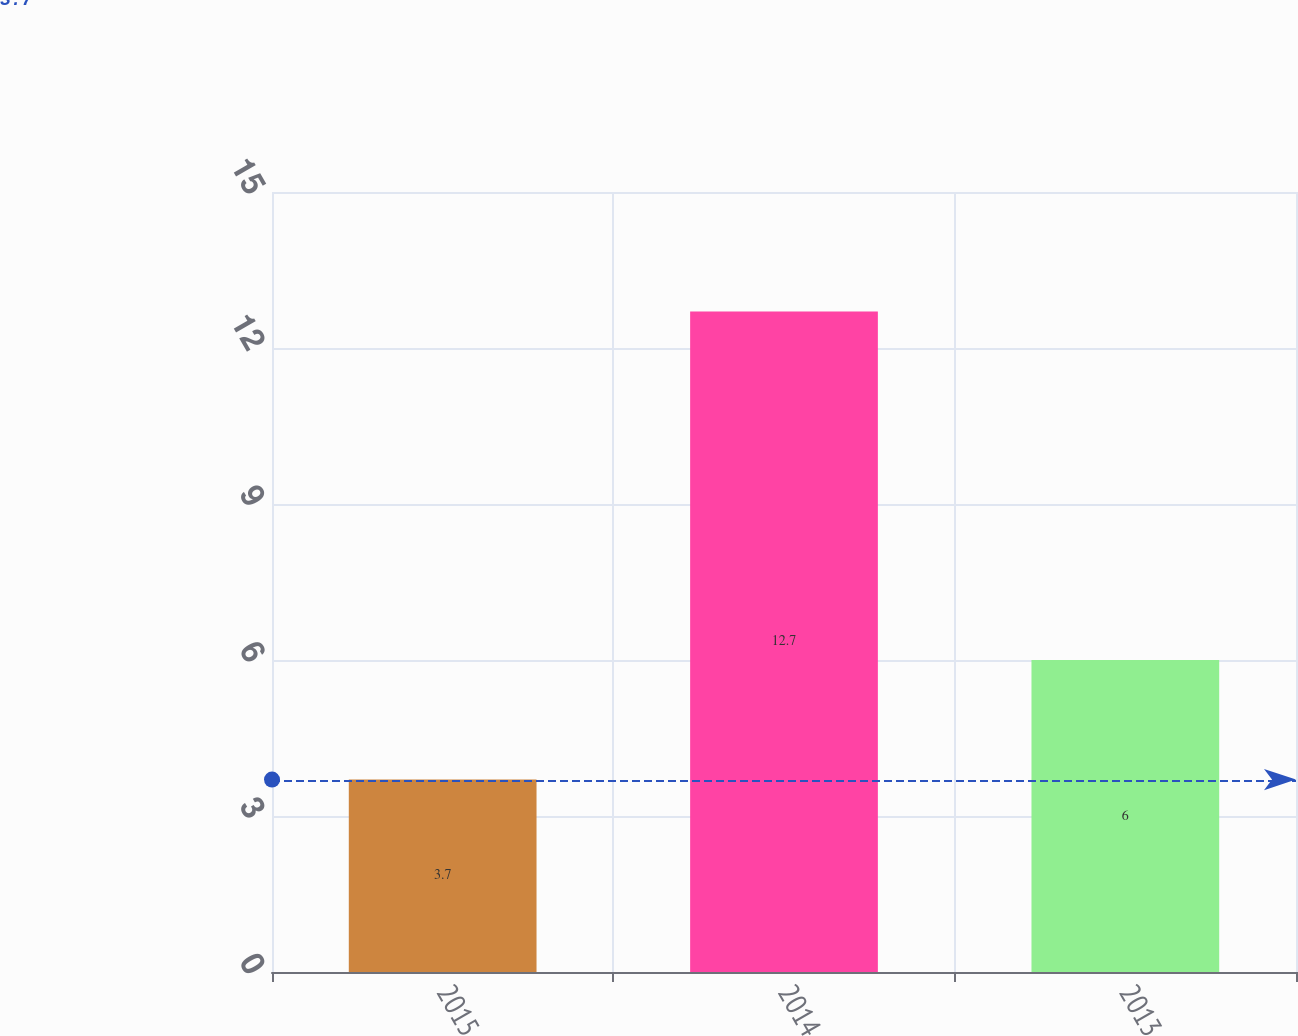<chart> <loc_0><loc_0><loc_500><loc_500><bar_chart><fcel>2015<fcel>2014<fcel>2013<nl><fcel>3.7<fcel>12.7<fcel>6<nl></chart> 